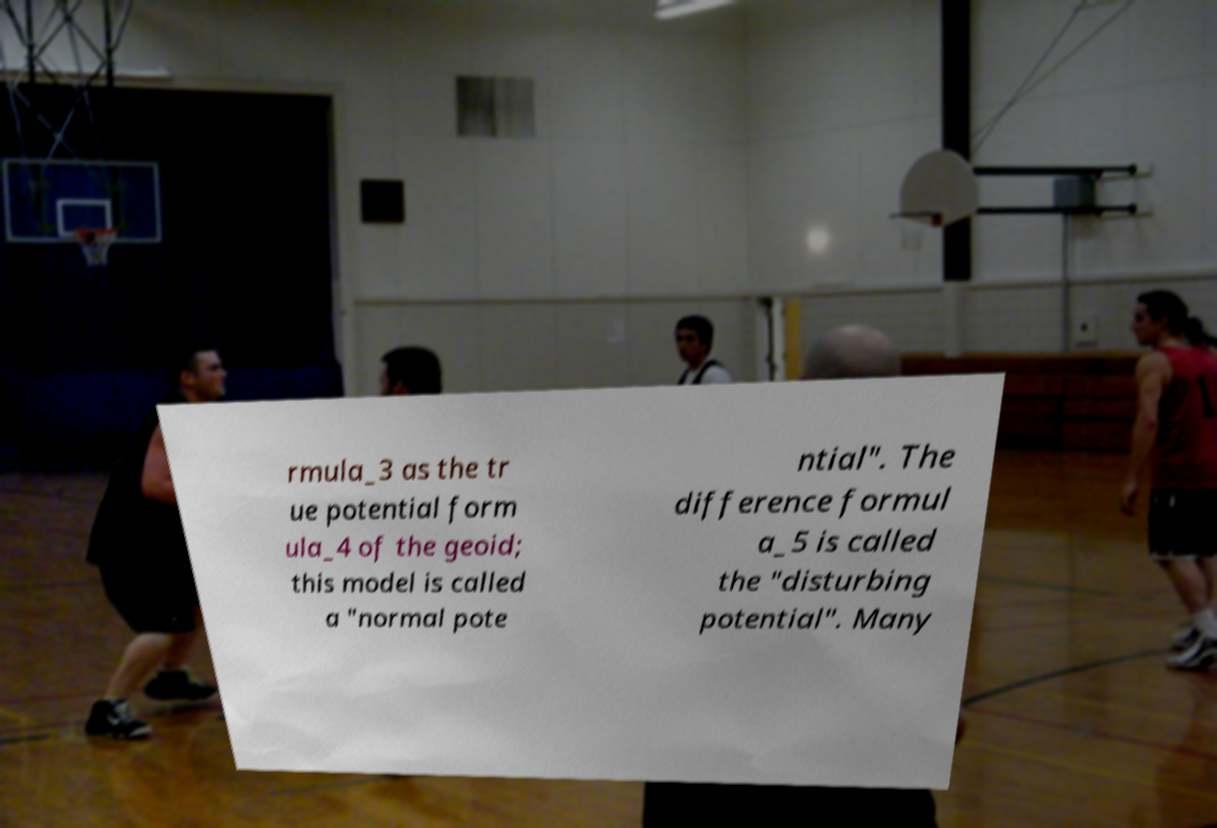There's text embedded in this image that I need extracted. Can you transcribe it verbatim? rmula_3 as the tr ue potential form ula_4 of the geoid; this model is called a "normal pote ntial". The difference formul a_5 is called the "disturbing potential". Many 